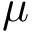Convert formula to latex. <formula><loc_0><loc_0><loc_500><loc_500>\mu</formula> 